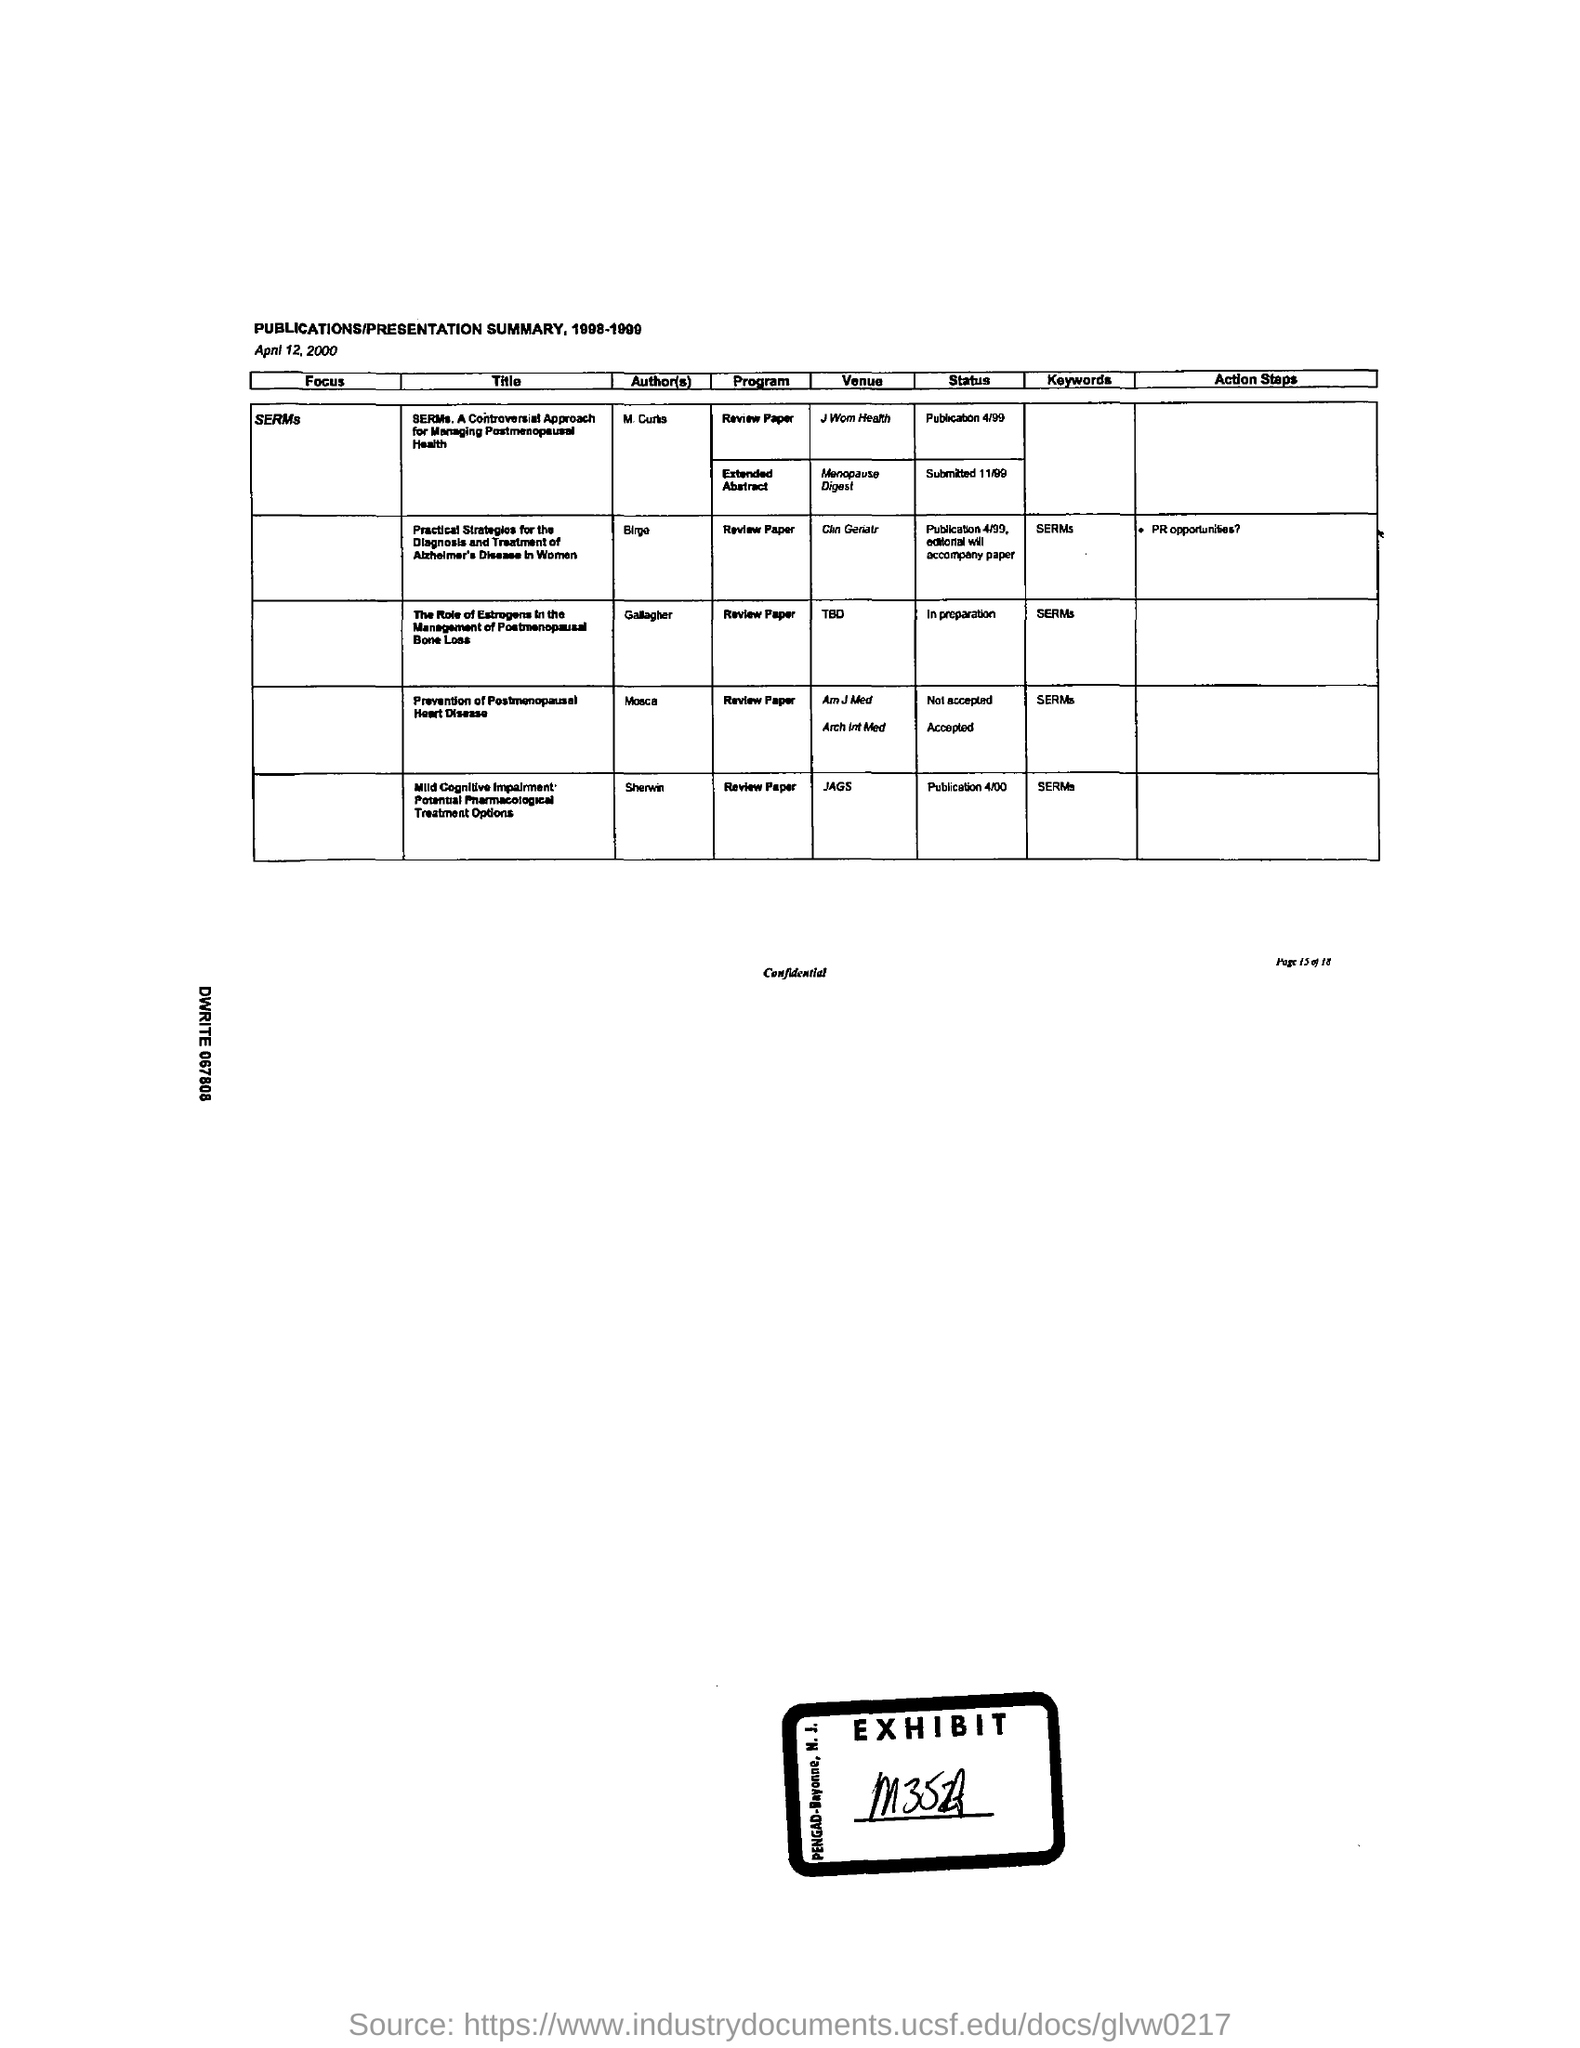Who is the author of prevention of postmenopausal heart disease?
Your response must be concise. Mosca. 